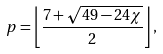Convert formula to latex. <formula><loc_0><loc_0><loc_500><loc_500>p = \left \lfloor { \frac { 7 + { \sqrt { 4 9 - 2 4 \chi } } } { 2 } } \right \rfloor ,</formula> 